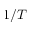<formula> <loc_0><loc_0><loc_500><loc_500>1 / T</formula> 